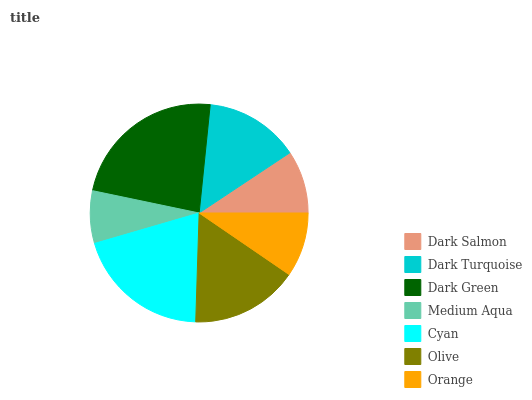Is Medium Aqua the minimum?
Answer yes or no. Yes. Is Dark Green the maximum?
Answer yes or no. Yes. Is Dark Turquoise the minimum?
Answer yes or no. No. Is Dark Turquoise the maximum?
Answer yes or no. No. Is Dark Turquoise greater than Dark Salmon?
Answer yes or no. Yes. Is Dark Salmon less than Dark Turquoise?
Answer yes or no. Yes. Is Dark Salmon greater than Dark Turquoise?
Answer yes or no. No. Is Dark Turquoise less than Dark Salmon?
Answer yes or no. No. Is Dark Turquoise the high median?
Answer yes or no. Yes. Is Dark Turquoise the low median?
Answer yes or no. Yes. Is Dark Salmon the high median?
Answer yes or no. No. Is Medium Aqua the low median?
Answer yes or no. No. 